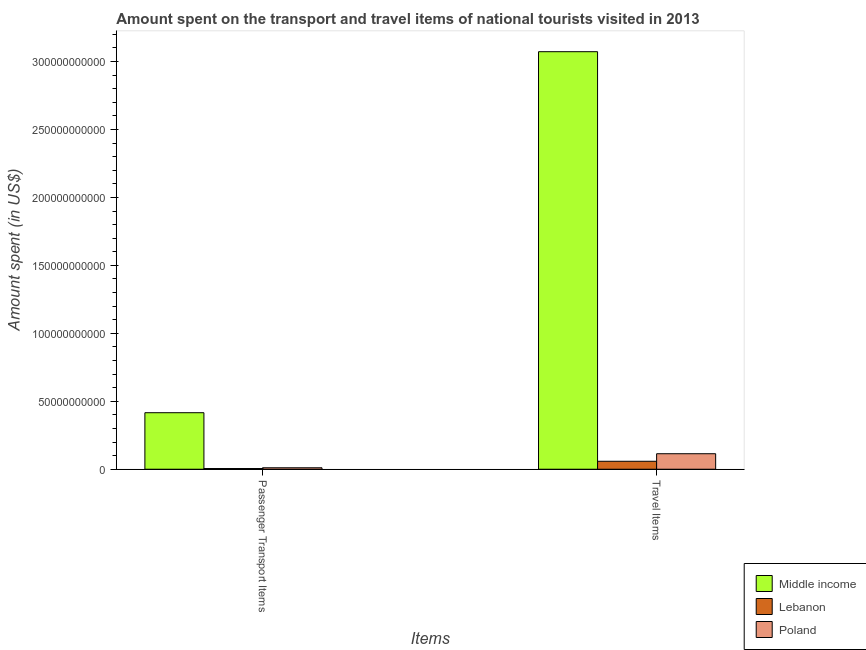How many different coloured bars are there?
Provide a succinct answer. 3. How many groups of bars are there?
Provide a succinct answer. 2. Are the number of bars on each tick of the X-axis equal?
Your answer should be very brief. Yes. What is the label of the 2nd group of bars from the left?
Ensure brevity in your answer.  Travel Items. What is the amount spent in travel items in Lebanon?
Your response must be concise. 5.86e+09. Across all countries, what is the maximum amount spent on passenger transport items?
Your answer should be compact. 4.16e+1. Across all countries, what is the minimum amount spent on passenger transport items?
Ensure brevity in your answer.  5.14e+08. In which country was the amount spent on passenger transport items maximum?
Give a very brief answer. Middle income. In which country was the amount spent in travel items minimum?
Ensure brevity in your answer.  Lebanon. What is the total amount spent on passenger transport items in the graph?
Your answer should be compact. 4.32e+1. What is the difference between the amount spent on passenger transport items in Poland and that in Lebanon?
Provide a short and direct response. 5.55e+08. What is the difference between the amount spent in travel items in Lebanon and the amount spent on passenger transport items in Poland?
Make the answer very short. 4.79e+09. What is the average amount spent in travel items per country?
Give a very brief answer. 1.08e+11. What is the difference between the amount spent in travel items and amount spent on passenger transport items in Lebanon?
Your answer should be compact. 5.34e+09. What is the ratio of the amount spent in travel items in Lebanon to that in Middle income?
Your answer should be very brief. 0.02. What does the 1st bar from the right in Travel Items represents?
Your response must be concise. Poland. How many bars are there?
Your answer should be very brief. 6. How many countries are there in the graph?
Make the answer very short. 3. Does the graph contain any zero values?
Provide a succinct answer. No. Where does the legend appear in the graph?
Provide a short and direct response. Bottom right. How many legend labels are there?
Provide a succinct answer. 3. How are the legend labels stacked?
Offer a very short reply. Vertical. What is the title of the graph?
Offer a very short reply. Amount spent on the transport and travel items of national tourists visited in 2013. Does "Jordan" appear as one of the legend labels in the graph?
Ensure brevity in your answer.  No. What is the label or title of the X-axis?
Your answer should be very brief. Items. What is the label or title of the Y-axis?
Ensure brevity in your answer.  Amount spent (in US$). What is the Amount spent (in US$) of Middle income in Passenger Transport Items?
Keep it short and to the point. 4.16e+1. What is the Amount spent (in US$) in Lebanon in Passenger Transport Items?
Your answer should be compact. 5.14e+08. What is the Amount spent (in US$) in Poland in Passenger Transport Items?
Provide a short and direct response. 1.07e+09. What is the Amount spent (in US$) in Middle income in Travel Items?
Make the answer very short. 3.07e+11. What is the Amount spent (in US$) in Lebanon in Travel Items?
Your response must be concise. 5.86e+09. What is the Amount spent (in US$) in Poland in Travel Items?
Your response must be concise. 1.14e+1. Across all Items, what is the maximum Amount spent (in US$) of Middle income?
Your answer should be very brief. 3.07e+11. Across all Items, what is the maximum Amount spent (in US$) of Lebanon?
Keep it short and to the point. 5.86e+09. Across all Items, what is the maximum Amount spent (in US$) in Poland?
Offer a very short reply. 1.14e+1. Across all Items, what is the minimum Amount spent (in US$) in Middle income?
Keep it short and to the point. 4.16e+1. Across all Items, what is the minimum Amount spent (in US$) of Lebanon?
Offer a terse response. 5.14e+08. Across all Items, what is the minimum Amount spent (in US$) of Poland?
Provide a succinct answer. 1.07e+09. What is the total Amount spent (in US$) of Middle income in the graph?
Provide a succinct answer. 3.49e+11. What is the total Amount spent (in US$) of Lebanon in the graph?
Offer a terse response. 6.37e+09. What is the total Amount spent (in US$) of Poland in the graph?
Offer a very short reply. 1.25e+1. What is the difference between the Amount spent (in US$) of Middle income in Passenger Transport Items and that in Travel Items?
Offer a terse response. -2.66e+11. What is the difference between the Amount spent (in US$) in Lebanon in Passenger Transport Items and that in Travel Items?
Ensure brevity in your answer.  -5.34e+09. What is the difference between the Amount spent (in US$) in Poland in Passenger Transport Items and that in Travel Items?
Make the answer very short. -1.03e+1. What is the difference between the Amount spent (in US$) in Middle income in Passenger Transport Items and the Amount spent (in US$) in Lebanon in Travel Items?
Your answer should be compact. 3.57e+1. What is the difference between the Amount spent (in US$) in Middle income in Passenger Transport Items and the Amount spent (in US$) in Poland in Travel Items?
Offer a terse response. 3.02e+1. What is the difference between the Amount spent (in US$) of Lebanon in Passenger Transport Items and the Amount spent (in US$) of Poland in Travel Items?
Offer a terse response. -1.09e+1. What is the average Amount spent (in US$) in Middle income per Items?
Your answer should be very brief. 1.74e+11. What is the average Amount spent (in US$) in Lebanon per Items?
Your answer should be very brief. 3.19e+09. What is the average Amount spent (in US$) in Poland per Items?
Your answer should be compact. 6.24e+09. What is the difference between the Amount spent (in US$) of Middle income and Amount spent (in US$) of Lebanon in Passenger Transport Items?
Offer a very short reply. 4.11e+1. What is the difference between the Amount spent (in US$) of Middle income and Amount spent (in US$) of Poland in Passenger Transport Items?
Give a very brief answer. 4.05e+1. What is the difference between the Amount spent (in US$) of Lebanon and Amount spent (in US$) of Poland in Passenger Transport Items?
Provide a succinct answer. -5.55e+08. What is the difference between the Amount spent (in US$) in Middle income and Amount spent (in US$) in Lebanon in Travel Items?
Give a very brief answer. 3.01e+11. What is the difference between the Amount spent (in US$) of Middle income and Amount spent (in US$) of Poland in Travel Items?
Provide a succinct answer. 2.96e+11. What is the difference between the Amount spent (in US$) of Lebanon and Amount spent (in US$) of Poland in Travel Items?
Ensure brevity in your answer.  -5.55e+09. What is the ratio of the Amount spent (in US$) of Middle income in Passenger Transport Items to that in Travel Items?
Provide a succinct answer. 0.14. What is the ratio of the Amount spent (in US$) of Lebanon in Passenger Transport Items to that in Travel Items?
Provide a short and direct response. 0.09. What is the ratio of the Amount spent (in US$) of Poland in Passenger Transport Items to that in Travel Items?
Offer a terse response. 0.09. What is the difference between the highest and the second highest Amount spent (in US$) in Middle income?
Give a very brief answer. 2.66e+11. What is the difference between the highest and the second highest Amount spent (in US$) in Lebanon?
Give a very brief answer. 5.34e+09. What is the difference between the highest and the second highest Amount spent (in US$) of Poland?
Ensure brevity in your answer.  1.03e+1. What is the difference between the highest and the lowest Amount spent (in US$) in Middle income?
Ensure brevity in your answer.  2.66e+11. What is the difference between the highest and the lowest Amount spent (in US$) of Lebanon?
Ensure brevity in your answer.  5.34e+09. What is the difference between the highest and the lowest Amount spent (in US$) in Poland?
Provide a succinct answer. 1.03e+1. 